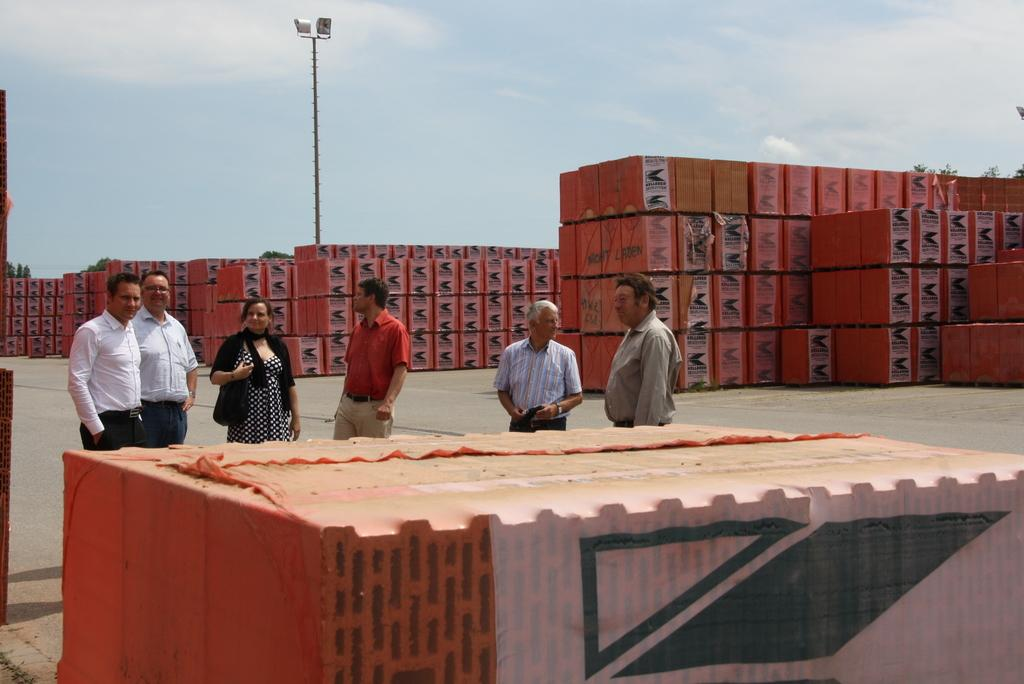How many men are in the image? There are two men in the image. What are the men wearing? Both men are wearing white shirts. Is there a woman in the image? Yes, there is a woman standing beside the men. What is the woman wearing? The woman is wearing a black dress. How would you describe the weather based on the sky in the image? The sky is cloudy in the image, suggesting a potentially overcast or cloudy day. Can you tell me how many goldfish are swimming in the pond in the image? There is no pond or goldfish present in the image; it features two men and a woman standing together. What type of pig can be seen playing with the woman in the image? There is no pig present in the image; it only features the two men and the woman. 